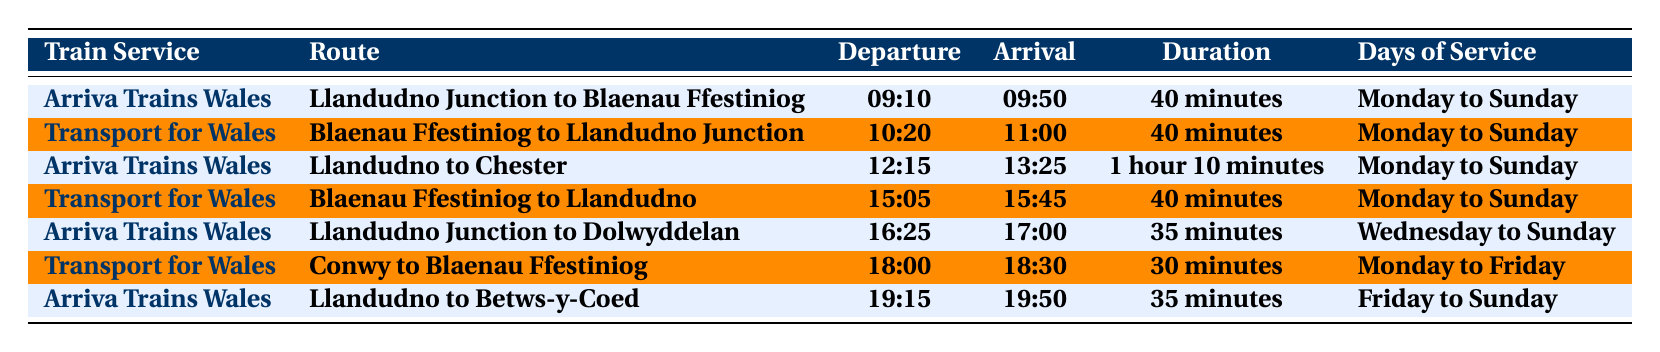What is the departure time for the train from Llandudno Junction to Blaenau Ffestiniog? The table shows that the departure time for that route is listed under the "Departure Time" column corresponding to the "Llandudno Junction to Blaenau Ffestiniog" row. The departure time is 09:10.
Answer: 09:10 Which train service operates the route from Blaenau Ffestiniog to Llandudno Junction? By looking at the route "Blaenau Ffestiniog to Llandudno Junction" in the table, we can see that the service is operated by "Transport for Wales."
Answer: Transport for Wales How many minutes does the train from Conwy to Blaenau Ffestiniog take to arrive? The "Duration" column for the route "Conwy to Blaenau Ffestiniog" shows 30 minutes as the amount of time it takes for the train to arrive.
Answer: 30 minutes Are there any trains that run from Llandudno Junction to Dolwyddelan on Tuesdays? The "Days of Service" for the route "Llandudno Junction to Dolwyddelan" indicates service only from Wednesday to Sunday, thus there is no service on Tuesdays.
Answer: No What is the duration of the train ride from Llandudno to Chester? The "Duration" for the train ride from Llandudno to Chester is found in the appropriate row, which lists 1 hour and 10 minutes.
Answer: 1 hour 10 minutes How many different train services are listed in the table? By reviewing the "Train Service" column, we can identify that there are two distinct services: "Arriva Trains Wales" and "Transport for Wales," making a total of 2 services listed.
Answer: 2 Which route has the longest duration? The table shows the durations for each route. The longest duration is 1 hour and 10 minutes for the route from Llandudno to Chester.
Answer: Llandudno to Chester On which day of the week does the train from Llandudno Junction to Dolwyddelan not operate? The "Days of Service" for that route indicates it runs from Wednesday to Sunday, which means it does not operate on Monday and Tuesday.
Answer: Monday and Tuesday What is the average duration of all the train rides listed in the table? To calculate the average duration, convert each time to minutes (40, 40, 70, 40, 35, 30, 35), sum them up (40 + 40 + 70 + 40 + 35 + 30 + 35 = 320 minutes), and divide by the number of routes (7), yielding an average of approximately 45.71 minutes.
Answer: 45.71 minutes Is there a train service that operates from Conwy to Blaenau Ffestiniog on weekends? Since the "Days of Service" for the train from "Conwy to Blaenau Ffestiniog" indicates it only runs Monday to Friday, it does not operate on weekends.
Answer: No 